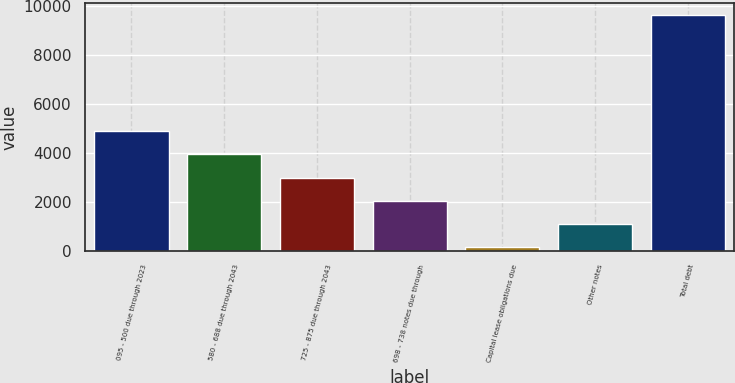Convert chart to OTSL. <chart><loc_0><loc_0><loc_500><loc_500><bar_chart><fcel>095 - 500 due through 2023<fcel>580 - 688 due through 2043<fcel>725 - 875 due through 2043<fcel>698 - 738 notes due through<fcel>Capital lease obligations due<fcel>Other notes<fcel>Total debt<nl><fcel>4893<fcel>3944.6<fcel>2996.2<fcel>2047.8<fcel>151<fcel>1099.4<fcel>9635<nl></chart> 